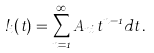<formula> <loc_0><loc_0><loc_500><loc_500>\omega _ { i } ( t ) = \sum _ { n = 1 } ^ { \infty } A _ { n i } t ^ { n - 1 } d t \, .</formula> 